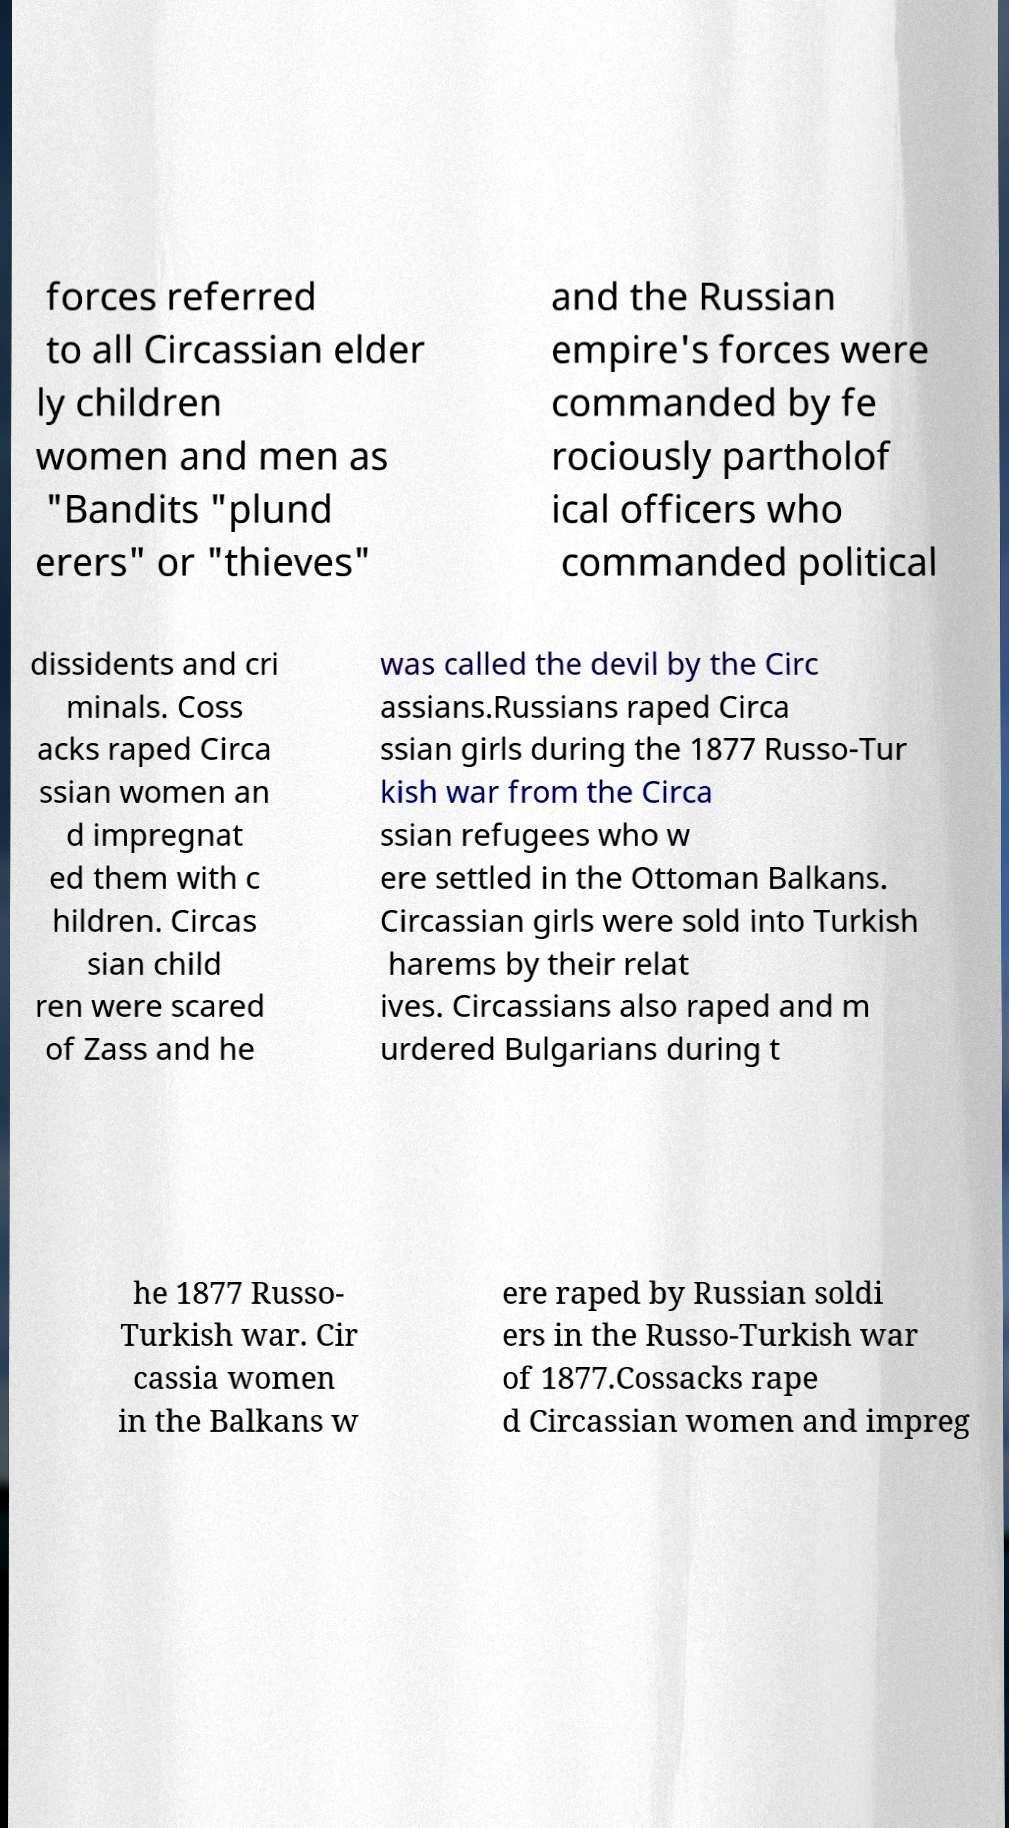There's text embedded in this image that I need extracted. Can you transcribe it verbatim? forces referred to all Circassian elder ly children women and men as "Bandits "plund erers" or "thieves" and the Russian empire's forces were commanded by fe rociously partholof ical officers who commanded political dissidents and cri minals. Coss acks raped Circa ssian women an d impregnat ed them with c hildren. Circas sian child ren were scared of Zass and he was called the devil by the Circ assians.Russians raped Circa ssian girls during the 1877 Russo-Tur kish war from the Circa ssian refugees who w ere settled in the Ottoman Balkans. Circassian girls were sold into Turkish harems by their relat ives. Circassians also raped and m urdered Bulgarians during t he 1877 Russo- Turkish war. Cir cassia women in the Balkans w ere raped by Russian soldi ers in the Russo-Turkish war of 1877.Cossacks rape d Circassian women and impreg 